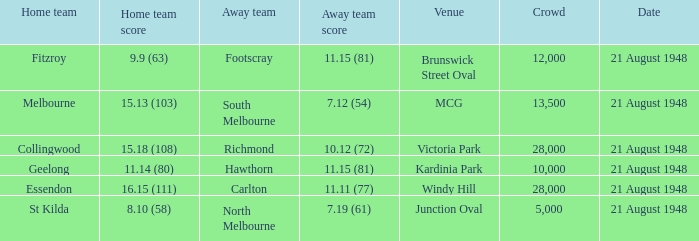If the Crowd is larger than 10,000 and the Away team score is 11.15 (81), what is the venue being played at? Brunswick Street Oval. Help me parse the entirety of this table. {'header': ['Home team', 'Home team score', 'Away team', 'Away team score', 'Venue', 'Crowd', 'Date'], 'rows': [['Fitzroy', '9.9 (63)', 'Footscray', '11.15 (81)', 'Brunswick Street Oval', '12,000', '21 August 1948'], ['Melbourne', '15.13 (103)', 'South Melbourne', '7.12 (54)', 'MCG', '13,500', '21 August 1948'], ['Collingwood', '15.18 (108)', 'Richmond', '10.12 (72)', 'Victoria Park', '28,000', '21 August 1948'], ['Geelong', '11.14 (80)', 'Hawthorn', '11.15 (81)', 'Kardinia Park', '10,000', '21 August 1948'], ['Essendon', '16.15 (111)', 'Carlton', '11.11 (77)', 'Windy Hill', '28,000', '21 August 1948'], ['St Kilda', '8.10 (58)', 'North Melbourne', '7.19 (61)', 'Junction Oval', '5,000', '21 August 1948']]} 